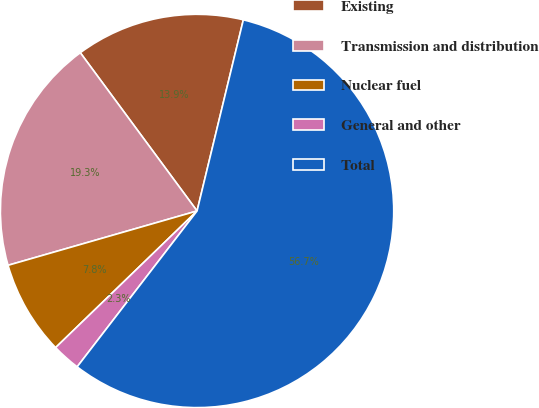<chart> <loc_0><loc_0><loc_500><loc_500><pie_chart><fcel>Existing<fcel>Transmission and distribution<fcel>Nuclear fuel<fcel>General and other<fcel>Total<nl><fcel>13.9%<fcel>19.34%<fcel>7.77%<fcel>2.34%<fcel>56.66%<nl></chart> 